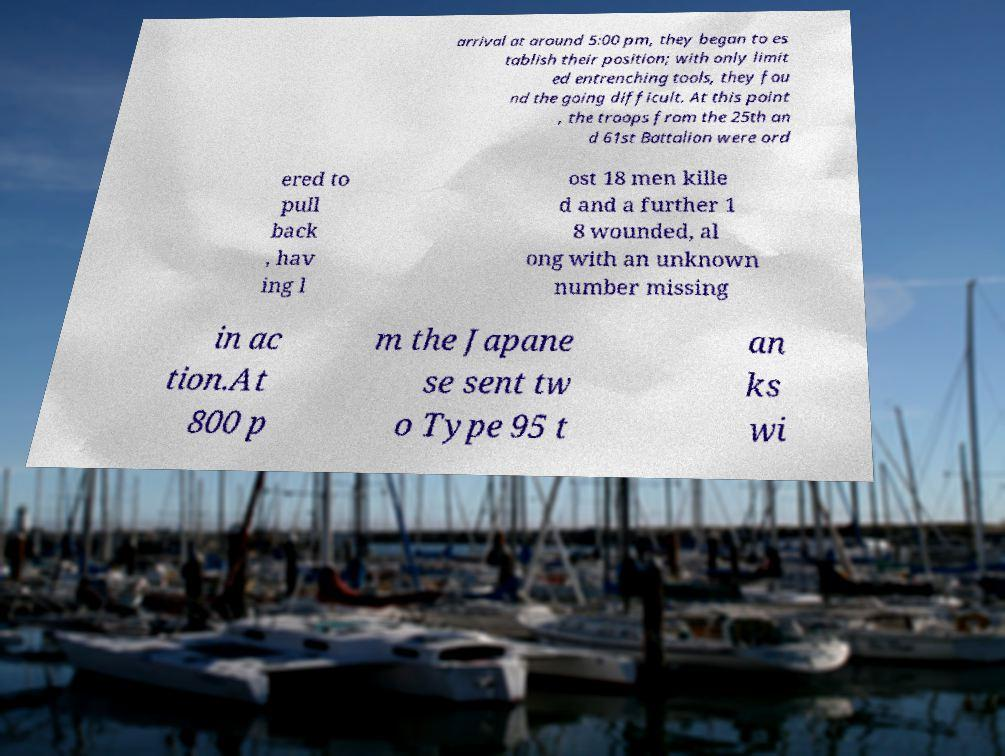For documentation purposes, I need the text within this image transcribed. Could you provide that? arrival at around 5:00 pm, they began to es tablish their position; with only limit ed entrenching tools, they fou nd the going difficult. At this point , the troops from the 25th an d 61st Battalion were ord ered to pull back , hav ing l ost 18 men kille d and a further 1 8 wounded, al ong with an unknown number missing in ac tion.At 800 p m the Japane se sent tw o Type 95 t an ks wi 